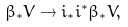Convert formula to latex. <formula><loc_0><loc_0><loc_500><loc_500>\beta _ { * } V \to i _ { * } i ^ { * } \beta _ { * } V ,</formula> 